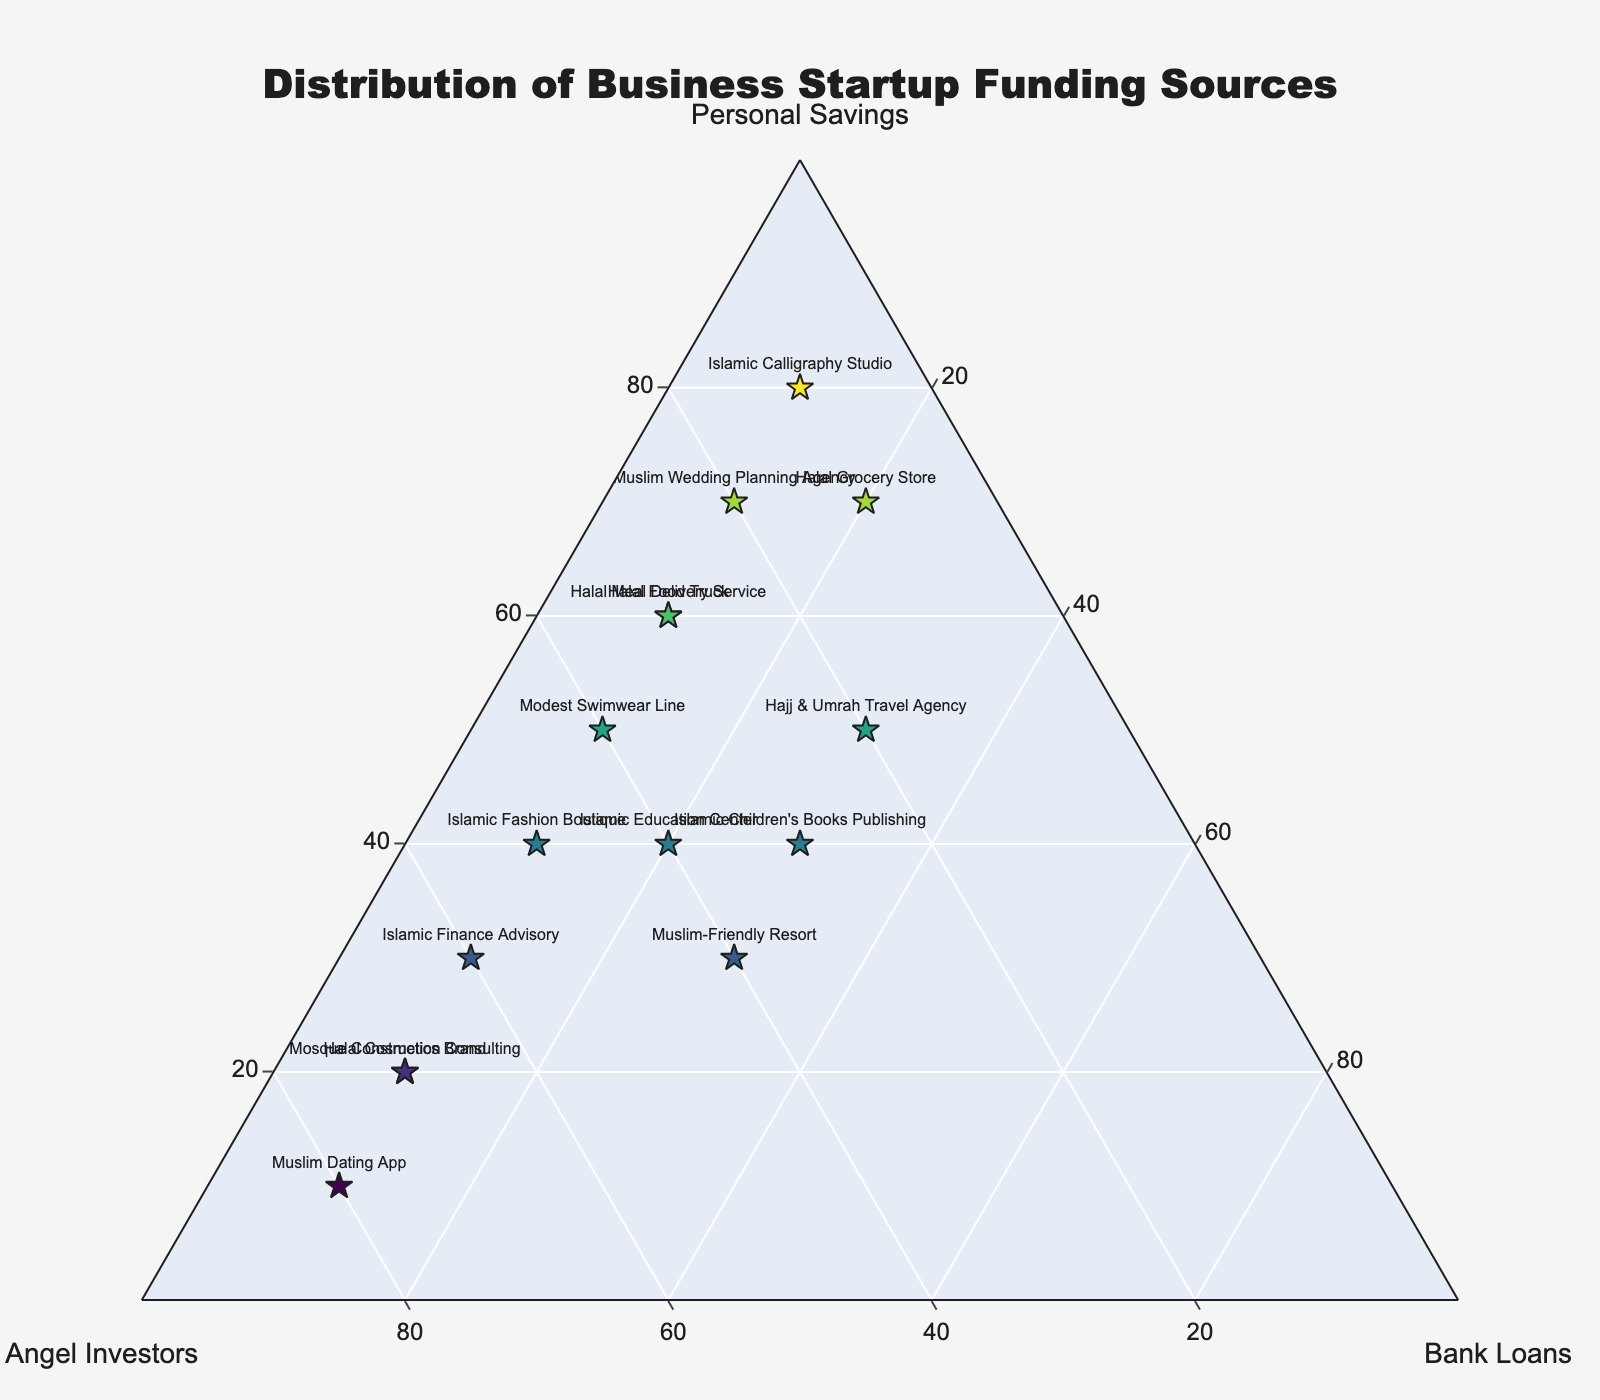How many businesses primarily rely on personal savings? Count the number of businesses where 'Personal Savings' value is the highest among the three funding sources.
Answer: 5 Which business has the highest percentage of angel investors? Identify the business with the highest value in the 'Angel Investors' column, which is 80%.
Answer: Muslim Dating App Which business has equal distribution of personal savings and angel investors? Check for a business where 'Personal Savings' and 'Angel Investors' values are equal.
Answer: Islamic Education Center What is the average percentage of bank loans among all businesses? Sum all the values in the 'Bank_Loans' column and divide by the number of businesses (15). (10+10+10+20+10+10+30+20+10+30+10+10+30+10+10) / 15 = 240/15.
Answer: 16 Which business has the most balanced distribution among the three funding sources? Identify the business with the smallest difference between the highest and lowest values among the three funding sources.
Answer: Muslim-Friendly Resort Which business relies the least on personal savings? Identify the business where the 'Personal Savings' value is the lowest, which is 10%.
Answer: Muslim Dating App How many businesses have a bank loan percentage higher than 20%? Count the number of businesses where 'Bank Loans' value is greater than 20%.
Answer: 2 Which funding source is most prominent for the Islamic Children's Books Publishing business? Identify the highest value among the three funding sources for 'Islamic Children's Books Publishing'.
Answer: Personal Savings For Halal Grocery Store, what is the combined percentage of angel investors and bank loans? Add the 'Angel Investors' value and 'Bank Loans' value for 'Halal Grocery Store' (10 + 20).
Answer: 30 Which business has the highest value for personal savings and what is that value? Identify the business with the highest 'Personal Savings' value and state the value, which is 80%.
Answer: Islamic Calligraphy Studio 